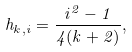<formula> <loc_0><loc_0><loc_500><loc_500>h _ { k , i } = \frac { i ^ { 2 } - 1 } { 4 ( k + 2 ) } ,</formula> 